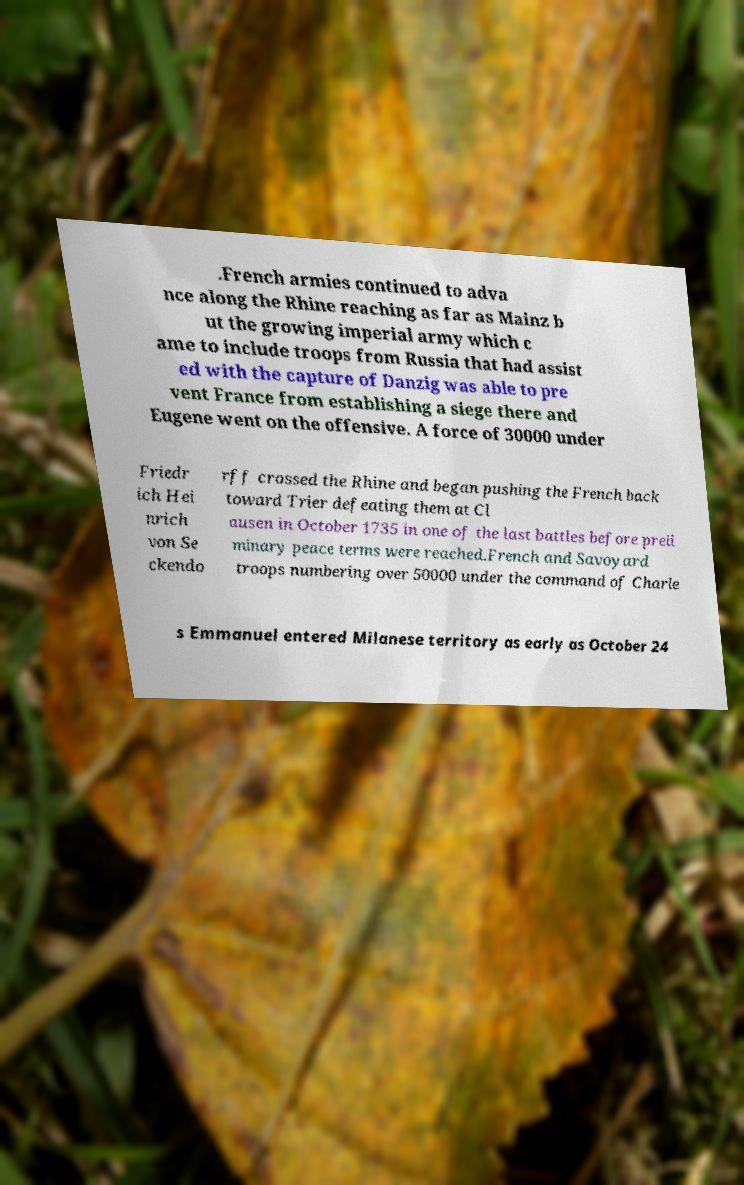Could you extract and type out the text from this image? .French armies continued to adva nce along the Rhine reaching as far as Mainz b ut the growing imperial army which c ame to include troops from Russia that had assist ed with the capture of Danzig was able to pre vent France from establishing a siege there and Eugene went on the offensive. A force of 30000 under Friedr ich Hei nrich von Se ckendo rff crossed the Rhine and began pushing the French back toward Trier defeating them at Cl ausen in October 1735 in one of the last battles before preli minary peace terms were reached.French and Savoyard troops numbering over 50000 under the command of Charle s Emmanuel entered Milanese territory as early as October 24 